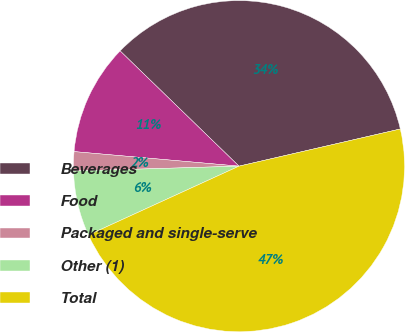Convert chart to OTSL. <chart><loc_0><loc_0><loc_500><loc_500><pie_chart><fcel>Beverages<fcel>Food<fcel>Packaged and single-serve<fcel>Other (1)<fcel>Total<nl><fcel>34.14%<fcel>10.85%<fcel>1.87%<fcel>6.36%<fcel>46.77%<nl></chart> 